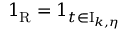Convert formula to latex. <formula><loc_0><loc_0><loc_500><loc_500>1 _ { R } = 1 _ { t \in I _ { k , \eta } }</formula> 